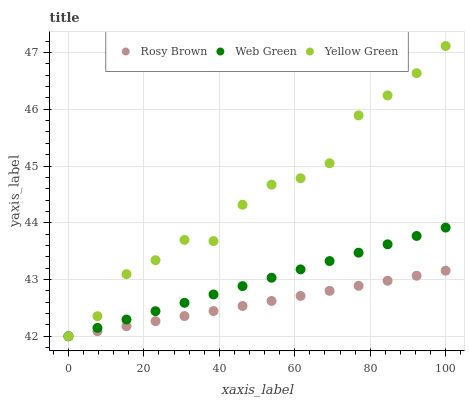Does Rosy Brown have the minimum area under the curve?
Answer yes or no. Yes. Does Yellow Green have the maximum area under the curve?
Answer yes or no. Yes. Does Web Green have the minimum area under the curve?
Answer yes or no. No. Does Web Green have the maximum area under the curve?
Answer yes or no. No. Is Web Green the smoothest?
Answer yes or no. Yes. Is Yellow Green the roughest?
Answer yes or no. Yes. Is Yellow Green the smoothest?
Answer yes or no. No. Is Web Green the roughest?
Answer yes or no. No. Does Rosy Brown have the lowest value?
Answer yes or no. Yes. Does Yellow Green have the highest value?
Answer yes or no. Yes. Does Web Green have the highest value?
Answer yes or no. No. Does Yellow Green intersect Rosy Brown?
Answer yes or no. Yes. Is Yellow Green less than Rosy Brown?
Answer yes or no. No. Is Yellow Green greater than Rosy Brown?
Answer yes or no. No. 